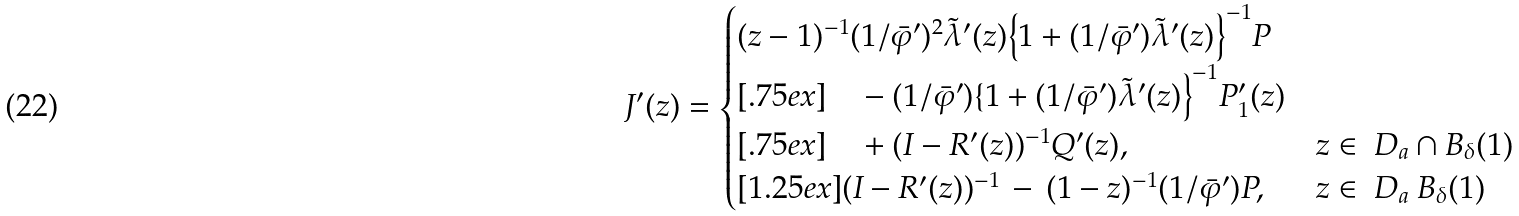Convert formula to latex. <formula><loc_0><loc_0><loc_500><loc_500>J ^ { \prime } ( z ) = \begin{cases} ( z - 1 ) ^ { - 1 } ( 1 / \bar { \varphi } ^ { \prime } ) ^ { 2 } \tilde { \lambda } ^ { \prime } ( z ) \Big \{ 1 + ( 1 / \bar { \varphi } ^ { \prime } ) \tilde { \lambda } ^ { \prime } ( z ) \Big \} ^ { - 1 } P \\ [ . 7 5 e x ] \quad - ( 1 / \bar { \varphi } ^ { \prime } ) \{ 1 + ( 1 / \bar { \varphi } ^ { \prime } ) \tilde { \lambda } ^ { \prime } ( z ) \Big \} ^ { - 1 } P _ { 1 } ^ { \prime } ( z ) \\ [ . 7 5 e x ] \quad + ( I - R ^ { \prime } ( z ) ) ^ { - 1 } Q ^ { \prime } ( z ) , & z \in \ D _ { a } \cap B _ { \delta } ( 1 ) \\ [ 1 . 2 5 e x ] ( I - R ^ { \prime } ( z ) ) ^ { - 1 } \, - \, ( 1 - z ) ^ { - 1 } ( 1 / \bar { \varphi } ^ { \prime } ) P , & z \in \ D _ { a } \ B _ { \delta } ( 1 ) \end{cases}</formula> 